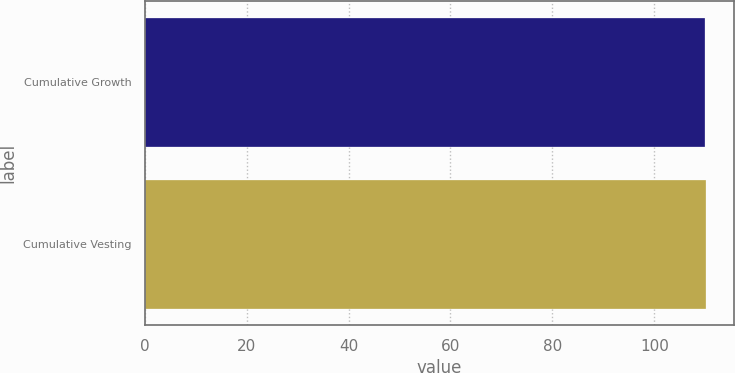Convert chart. <chart><loc_0><loc_0><loc_500><loc_500><bar_chart><fcel>Cumulative Growth<fcel>Cumulative Vesting<nl><fcel>110<fcel>110.1<nl></chart> 